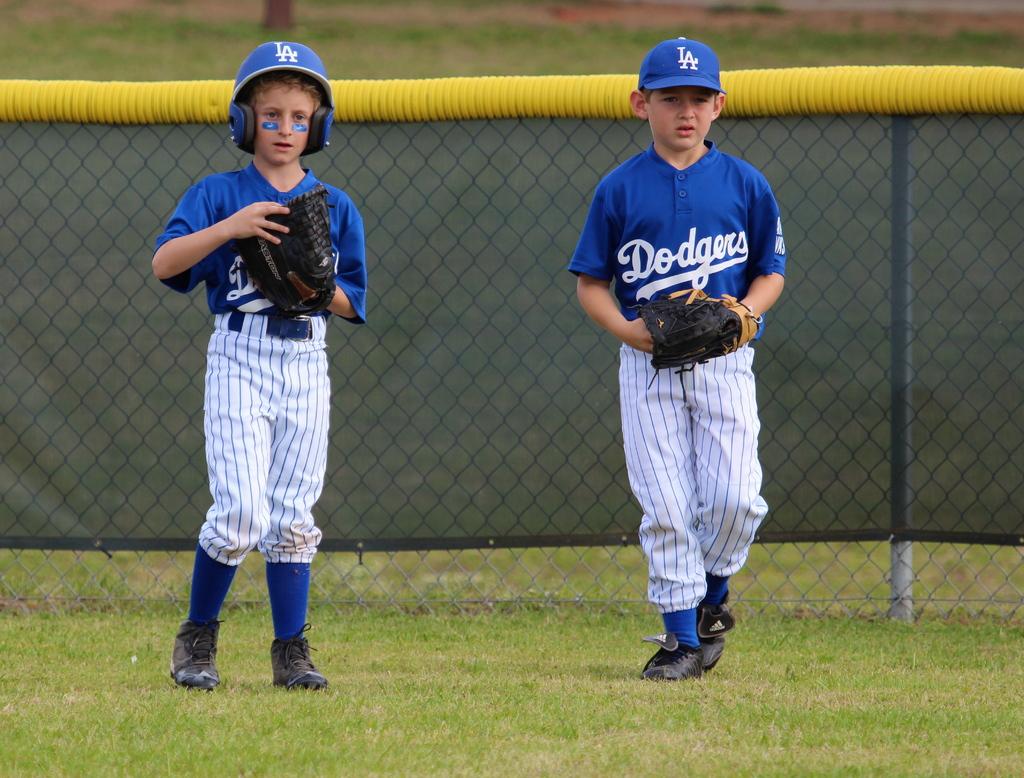What team do they belong to?
Keep it short and to the point. Dodgers. Text to small?
Your response must be concise. No. 